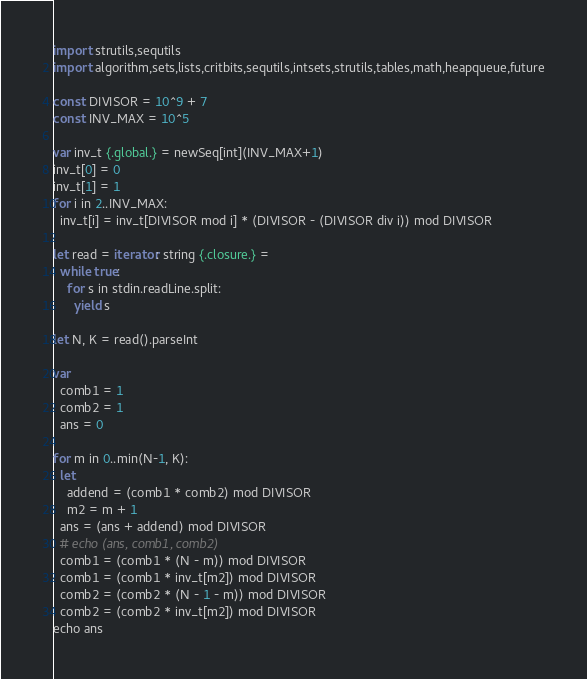<code> <loc_0><loc_0><loc_500><loc_500><_Nim_>import strutils,sequtils
import algorithm,sets,lists,critbits,sequtils,intsets,strutils,tables,math,heapqueue,future

const DIVISOR = 10^9 + 7
const INV_MAX = 10^5

var inv_t {.global.} = newSeq[int](INV_MAX+1)
inv_t[0] = 0
inv_t[1] = 1
for i in 2..INV_MAX:
  inv_t[i] = inv_t[DIVISOR mod i] * (DIVISOR - (DIVISOR div i)) mod DIVISOR

let read = iterator: string {.closure.} =
  while true:
    for s in stdin.readLine.split:
      yield s

let N, K = read().parseInt

var
  comb1 = 1
  comb2 = 1
  ans = 0

for m in 0..min(N-1, K):
  let
    addend = (comb1 * comb2) mod DIVISOR
    m2 = m + 1
  ans = (ans + addend) mod DIVISOR
  # echo (ans, comb1, comb2)
  comb1 = (comb1 * (N - m)) mod DIVISOR
  comb1 = (comb1 * inv_t[m2]) mod DIVISOR
  comb2 = (comb2 * (N - 1 - m)) mod DIVISOR
  comb2 = (comb2 * inv_t[m2]) mod DIVISOR
echo ans
</code> 